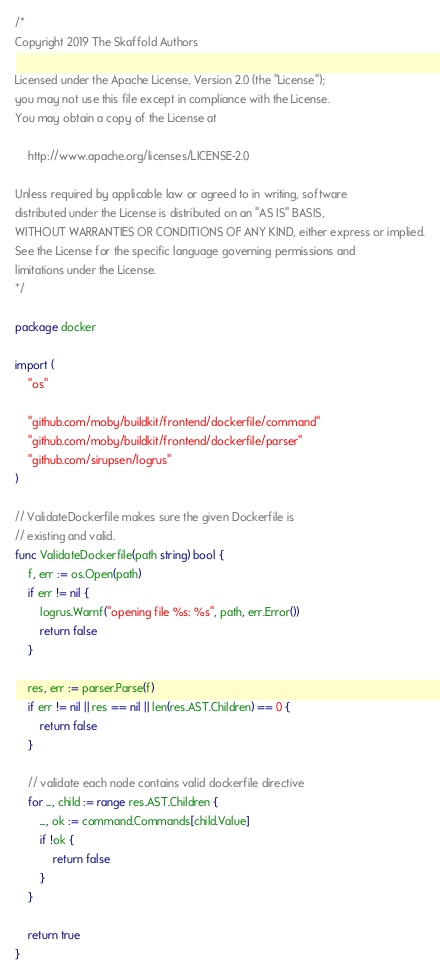Convert code to text. <code><loc_0><loc_0><loc_500><loc_500><_Go_>/*
Copyright 2019 The Skaffold Authors

Licensed under the Apache License, Version 2.0 (the "License");
you may not use this file except in compliance with the License.
You may obtain a copy of the License at

    http://www.apache.org/licenses/LICENSE-2.0

Unless required by applicable law or agreed to in writing, software
distributed under the License is distributed on an "AS IS" BASIS,
WITHOUT WARRANTIES OR CONDITIONS OF ANY KIND, either express or implied.
See the License for the specific language governing permissions and
limitations under the License.
*/

package docker

import (
	"os"

	"github.com/moby/buildkit/frontend/dockerfile/command"
	"github.com/moby/buildkit/frontend/dockerfile/parser"
	"github.com/sirupsen/logrus"
)

// ValidateDockerfile makes sure the given Dockerfile is
// existing and valid.
func ValidateDockerfile(path string) bool {
	f, err := os.Open(path)
	if err != nil {
		logrus.Warnf("opening file %s: %s", path, err.Error())
		return false
	}

	res, err := parser.Parse(f)
	if err != nil || res == nil || len(res.AST.Children) == 0 {
		return false
	}

	// validate each node contains valid dockerfile directive
	for _, child := range res.AST.Children {
		_, ok := command.Commands[child.Value]
		if !ok {
			return false
		}
	}

	return true
}
</code> 